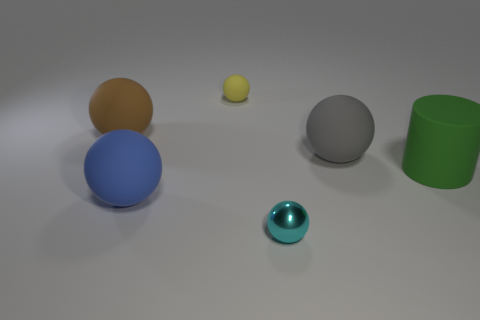Subtract all big blue balls. How many balls are left? 4 Subtract all blue balls. How many balls are left? 4 Subtract all green balls. Subtract all cyan cubes. How many balls are left? 5 Add 2 large brown spheres. How many objects exist? 8 Subtract all balls. How many objects are left? 1 Subtract 0 cyan cylinders. How many objects are left? 6 Subtract all cyan balls. Subtract all gray rubber balls. How many objects are left? 4 Add 5 big green cylinders. How many big green cylinders are left? 6 Add 4 large gray cylinders. How many large gray cylinders exist? 4 